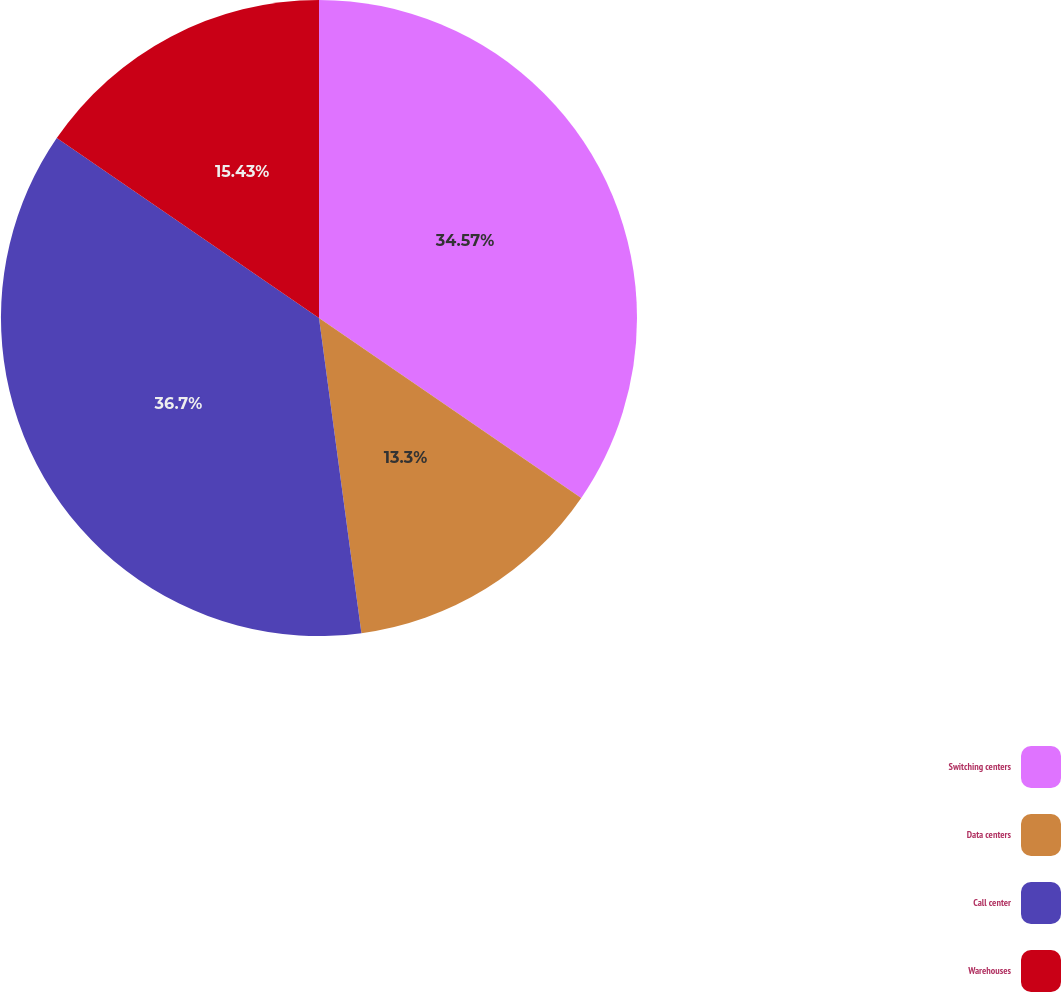<chart> <loc_0><loc_0><loc_500><loc_500><pie_chart><fcel>Switching centers<fcel>Data centers<fcel>Call center<fcel>Warehouses<nl><fcel>34.57%<fcel>13.3%<fcel>36.7%<fcel>15.43%<nl></chart> 